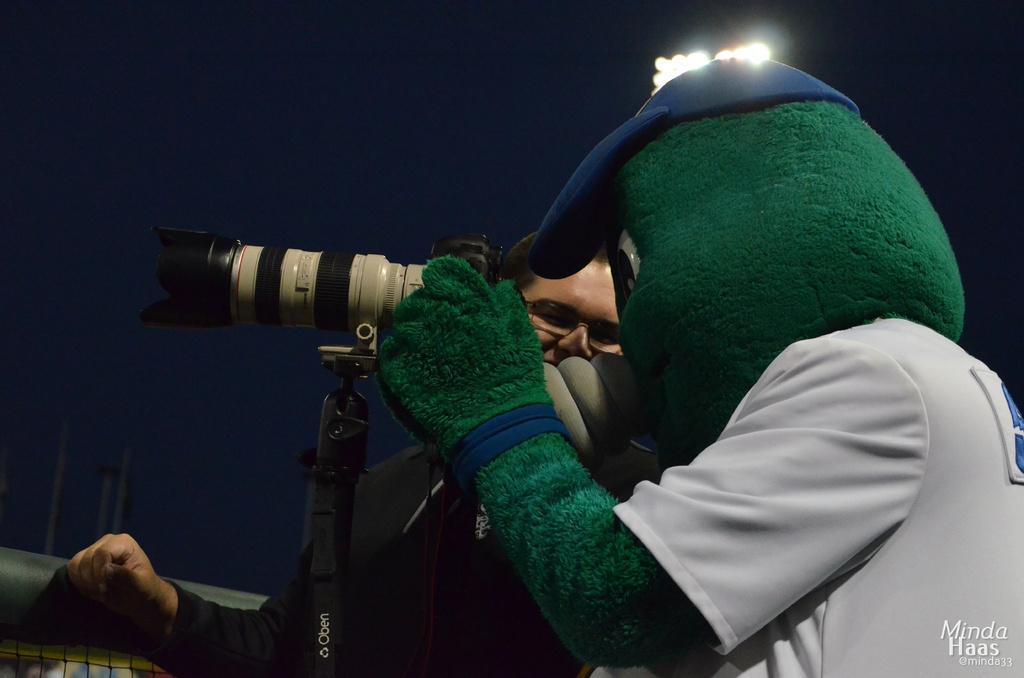Please provide a concise description of this image. In this picture we can see a there are two people standing and a person in the fancy dress is holding a camera. Behind the people there is the sky and poles. On the image there is a watermark. 